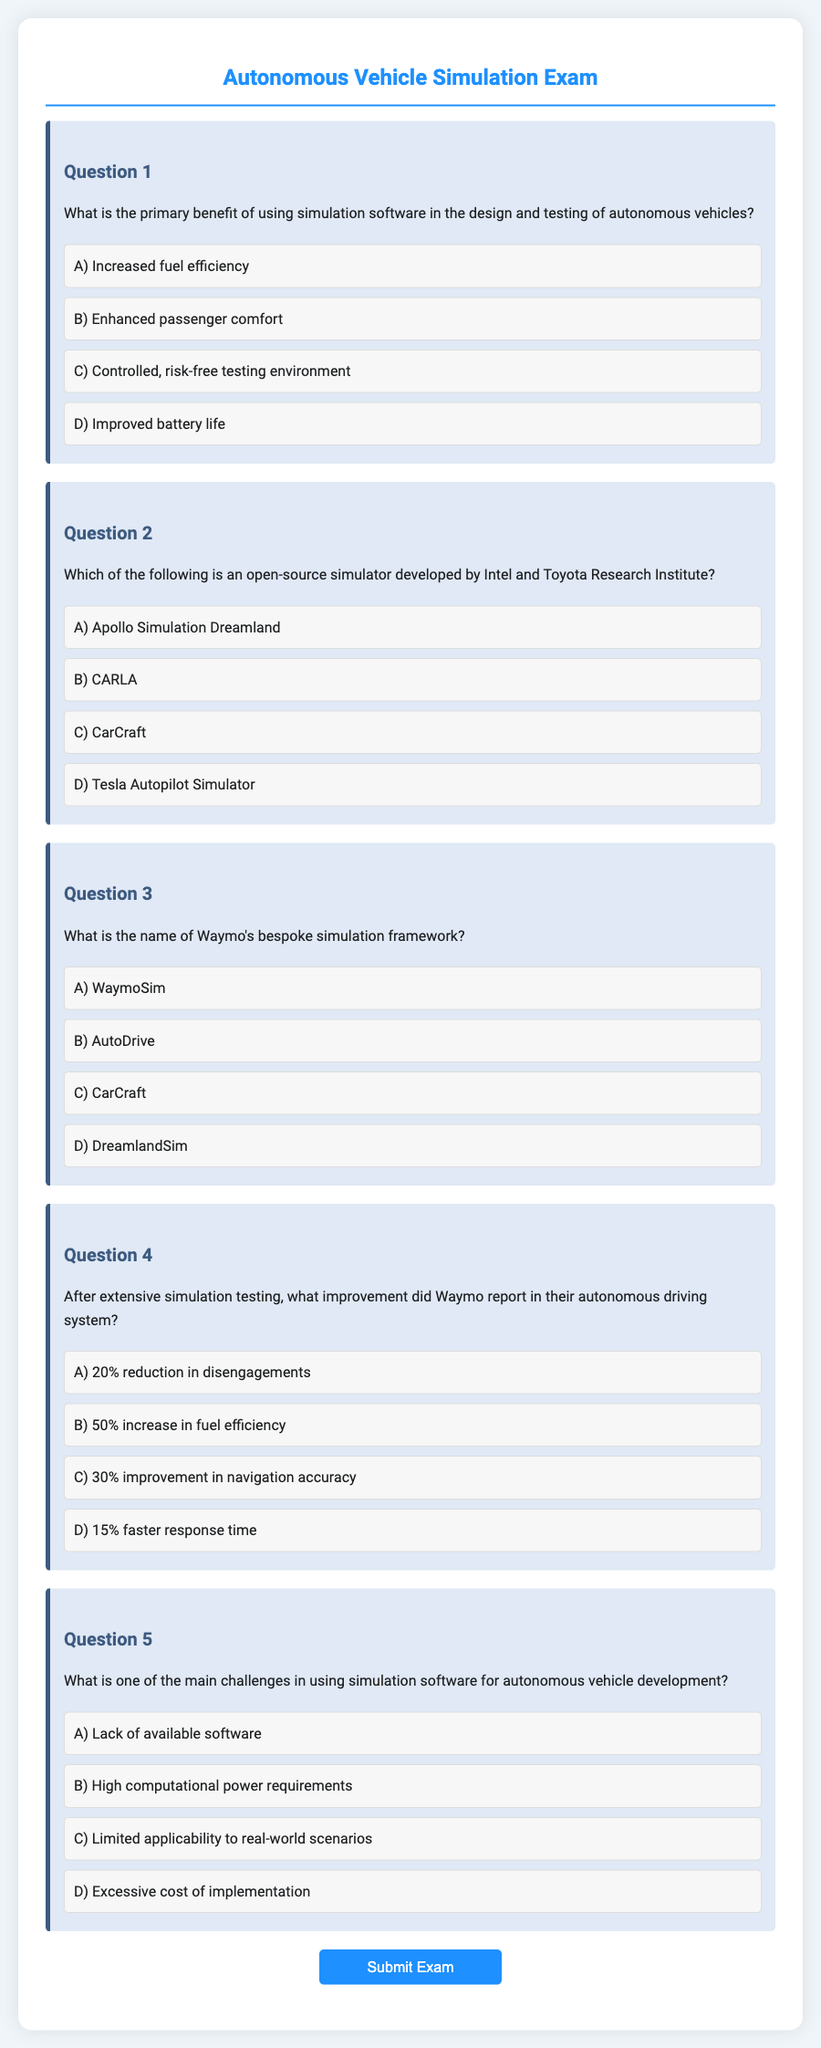What is the primary benefit of using simulation software? The document states that the primary benefit is having a controlled, risk-free testing environment.
Answer: Controlled, risk-free testing environment Which simulator is developed by Intel and Toyota Research Institute? The document indicates that CARLA is the open-source simulator developed by Intel and Toyota Research Institute.
Answer: CARLA What is Waymo's bespoke simulation framework named? The document reveals that WaymoSim is the name of their bespoke simulation framework.
Answer: WaymoSim What improvement did Waymo report in their autonomous driving system? The document mentions that Waymo reported a 20% reduction in disengagements after extensive simulation testing.
Answer: 20% reduction in disengagements What is one of the main challenges in using simulation software? The document highlights high computational power requirements as one of the main challenges.
Answer: High computational power requirements 